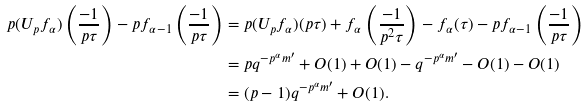<formula> <loc_0><loc_0><loc_500><loc_500>p ( U _ { p } f _ { \alpha } ) \left ( \frac { - 1 } { p \tau } \right ) - p f _ { \alpha - 1 } \left ( \frac { - 1 } { p \tau } \right ) & = p ( U _ { p } f _ { \alpha } ) ( p \tau ) + f _ { \alpha } \left ( \frac { - 1 } { p ^ { 2 } \tau } \right ) - f _ { \alpha } ( \tau ) - p f _ { \alpha - 1 } \left ( \frac { - 1 } { p \tau } \right ) \\ & = p q ^ { - p ^ { \alpha } m ^ { \prime } } + O ( 1 ) + O ( 1 ) - q ^ { - p ^ { \alpha } m ^ { \prime } } - O ( 1 ) - O ( 1 ) \\ & = ( p - 1 ) q ^ { - p ^ { \alpha } m ^ { \prime } } + O ( 1 ) .</formula> 